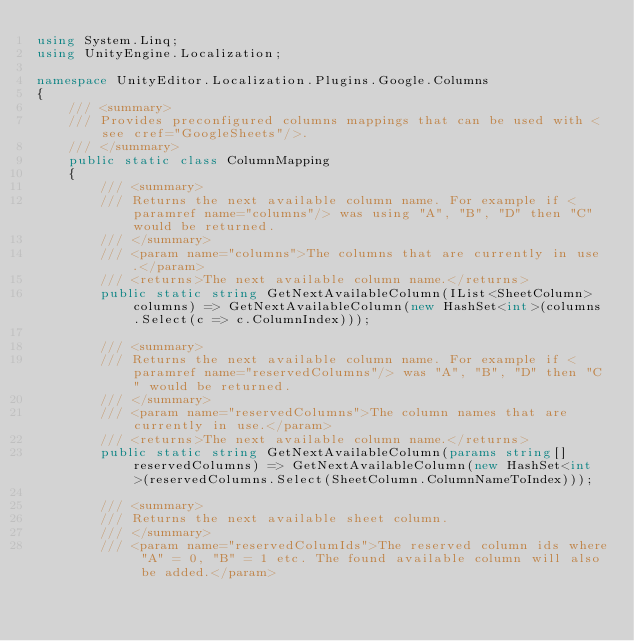<code> <loc_0><loc_0><loc_500><loc_500><_C#_>using System.Linq;
using UnityEngine.Localization;

namespace UnityEditor.Localization.Plugins.Google.Columns
{
    /// <summary>
    /// Provides preconfigured columns mappings that can be used with <see cref="GoogleSheets"/>.
    /// </summary>
    public static class ColumnMapping
    {
        /// <summary>
        /// Returns the next available column name. For example if <paramref name="columns"/> was using "A", "B", "D" then "C" would be returned.
        /// </summary>
        /// <param name="columns">The columns that are currently in use.</param>
        /// <returns>The next available column name.</returns>
        public static string GetNextAvailableColumn(IList<SheetColumn> columns) => GetNextAvailableColumn(new HashSet<int>(columns.Select(c => c.ColumnIndex)));

        /// <summary>
        /// Returns the next available column name. For example if <paramref name="reservedColumns"/> was "A", "B", "D" then "C" would be returned.
        /// </summary>
        /// <param name="reservedColumns">The column names that are currently in use.</param>
        /// <returns>The next available column name.</returns>
        public static string GetNextAvailableColumn(params string[] reservedColumns) => GetNextAvailableColumn(new HashSet<int>(reservedColumns.Select(SheetColumn.ColumnNameToIndex)));

        /// <summary>
        /// Returns the next available sheet column.
        /// </summary>
        /// <param name="reservedColumIds">The reserved column ids where "A" = 0, "B" = 1 etc. The found available column will also be added.</param></code> 